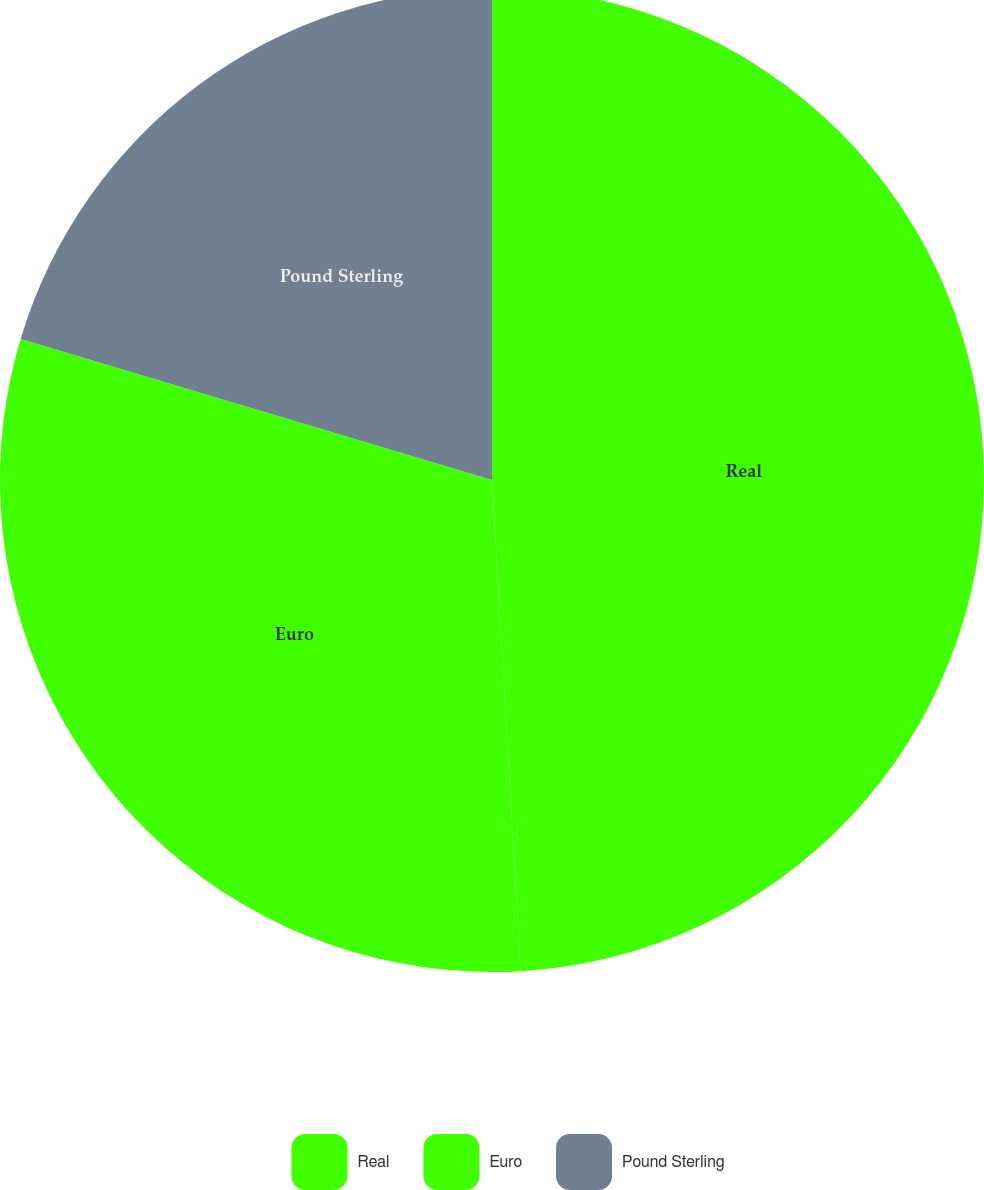Convert chart to OTSL. <chart><loc_0><loc_0><loc_500><loc_500><pie_chart><fcel>Real<fcel>Euro<fcel>Pound Sterling<nl><fcel>49.07%<fcel>30.56%<fcel>20.37%<nl></chart> 